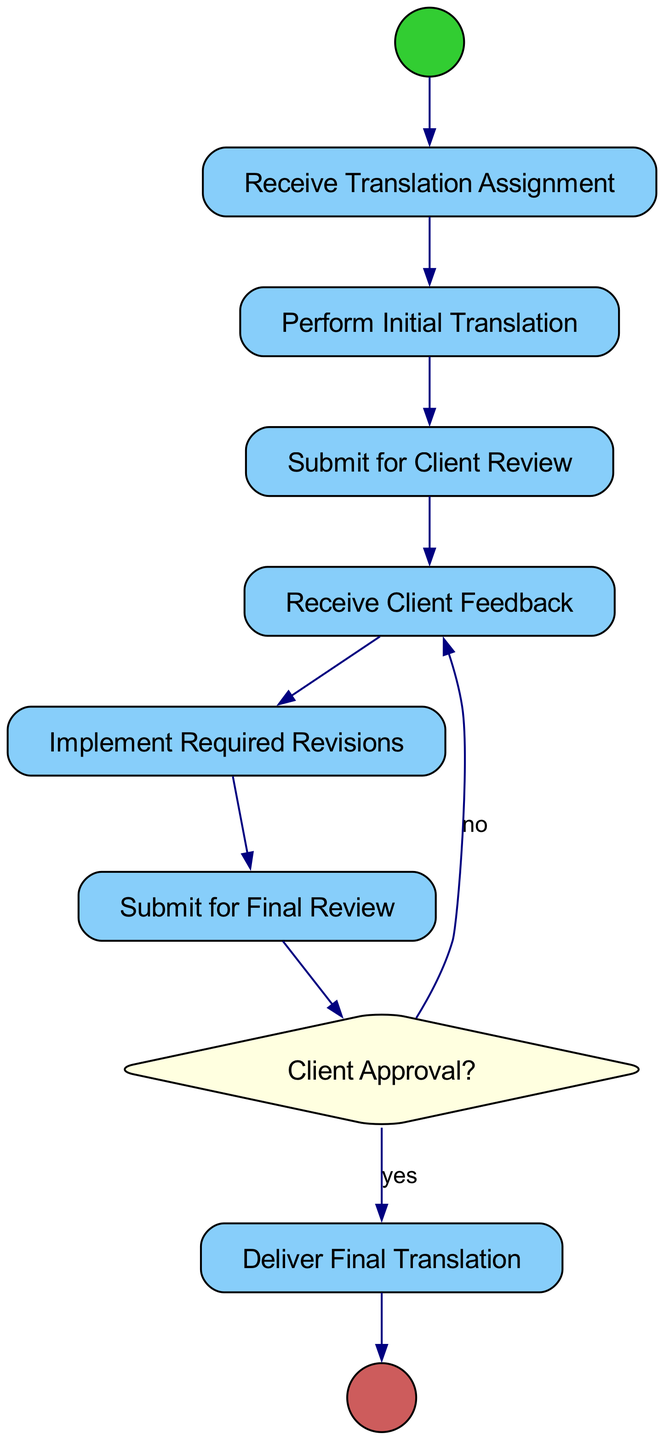What is the first activity in the diagram? The first activity is represented by the node following the start event, which is "Receive Translation Assignment."
Answer: Receive Translation Assignment How many decision points are in the diagram? The diagram contains one decision point, which is where client approval is assessed.
Answer: 1 What is the last activity before reaching the end? The last activity performed before reaching the end is "Deliver Final Translation."
Answer: Deliver Final Translation What happens after "Submit for Final Review"? After "Submit for Final Review," the next step is to evaluate client approval based on the decision node "Client Approval?"
Answer: Evaluate client approval If the client does not approve, which activity is repeated? If the client does not approve, the process returns to "Receive Client Feedback."
Answer: Receive Client Feedback What is the type of the last node in the flow? The last node is an end event, indicating the completion of the process.
Answer: end Event How does the flow proceed after "Implement Required Revisions"? After "Implement Required Revisions," the flow proceeds to "Submit for Final Review."
Answer: Submit for Final Review How many activities are involved in the cycle, excluding the start and end nodes? There are six activities involved in the cycle, excluding the start and end nodes.
Answer: 6 What condition leads to delivering the final translation? The condition that leads to delivering the final translation is "yes" from the "Client Approval?" decision node.
Answer: yes 